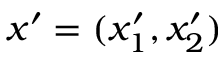Convert formula to latex. <formula><loc_0><loc_0><loc_500><loc_500>x ^ { \prime } = ( x _ { 1 } ^ { \prime } , x _ { 2 } ^ { \prime } )</formula> 